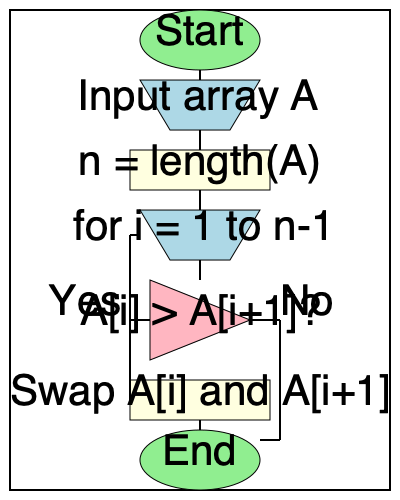Analyze the flowchart and identify the sorting algorithm it represents. What is the time complexity of this algorithm in the worst-case scenario? To identify the sorting algorithm and determine its worst-case time complexity, let's analyze the flowchart step-by-step:

1. The algorithm starts by inputting an array A.
2. It initializes n as the length of the array.
3. There's a loop that runs from i = 1 to n-1.
4. Inside the loop, there's a condition that compares adjacent elements A[i] and A[i+1].
5. If A[i] > A[i+1], the elements are swapped.
6. The loop continues until it reaches the end of the array.

These steps describe the Bubble Sort algorithm. Bubble Sort repeatedly steps through the list, compares adjacent elements, and swaps them if they are in the wrong order.

To determine the worst-case time complexity:

1. The outer loop runs n-1 times.
2. For each iteration of the outer loop, the inner comparison and potential swap operation is performed n-1 times in the first pass, n-2 times in the second pass, and so on.
3. This results in (n-1) + (n-2) + ... + 2 + 1 = n(n-1)/2 comparisons.
4. The swapping operation, if needed, takes constant time.

Therefore, the total number of operations is proportional to $n^2$, giving a worst-case time complexity of $O(n^2)$.
Answer: Bubble Sort, $O(n^2)$ 